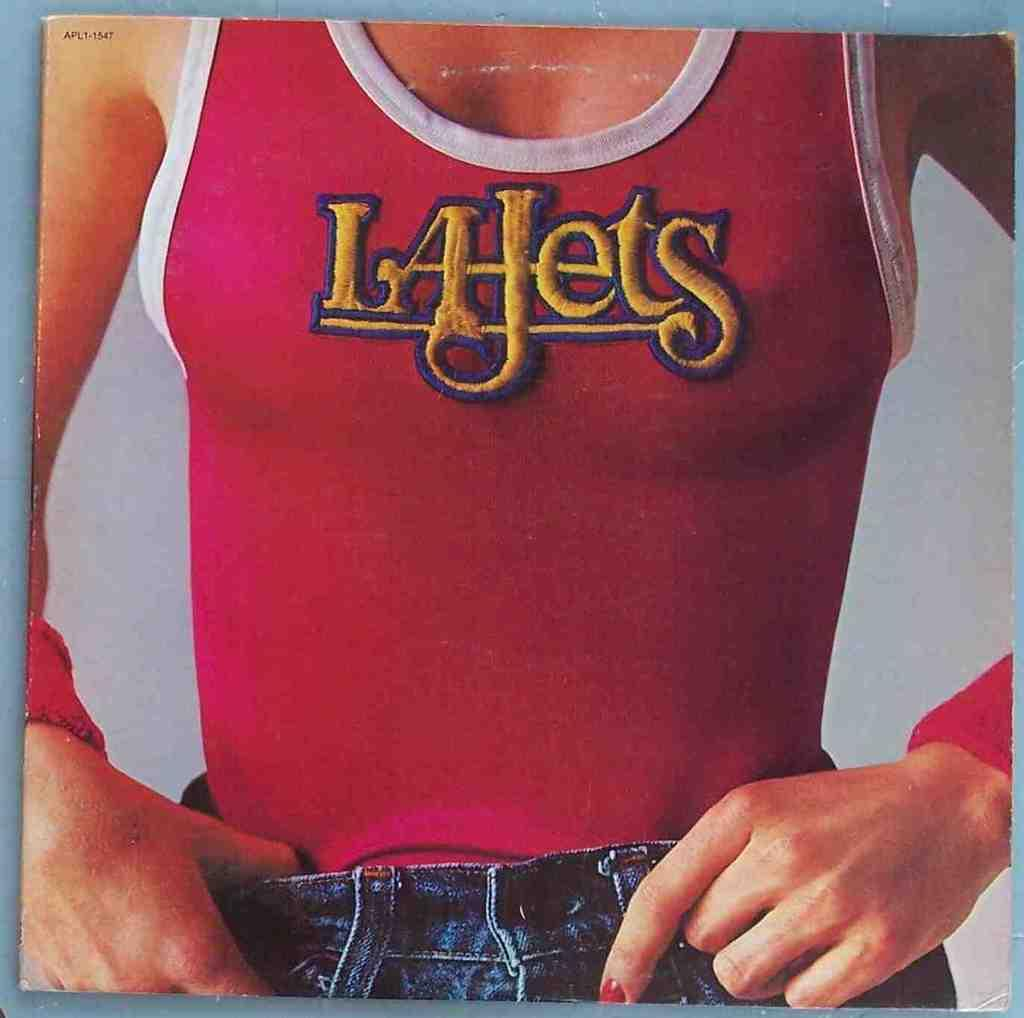<image>
Relay a brief, clear account of the picture shown. The woman is wearing a tight red La Jets tank top, and a pair of blue jeans. 